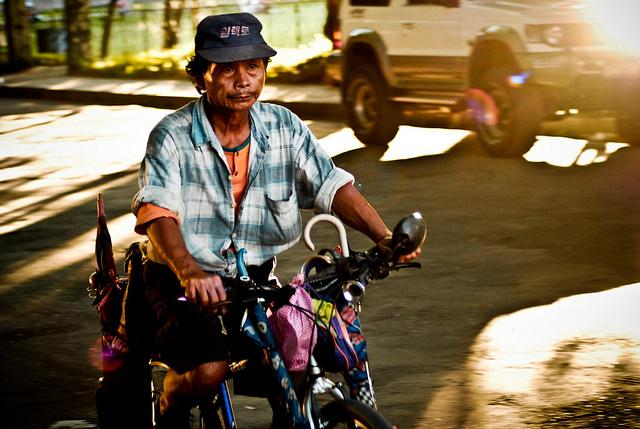Why do they have so many umbrellas?

Choices:
A) cleaning them
B) found them
C) selling them
D) stole them selling them 